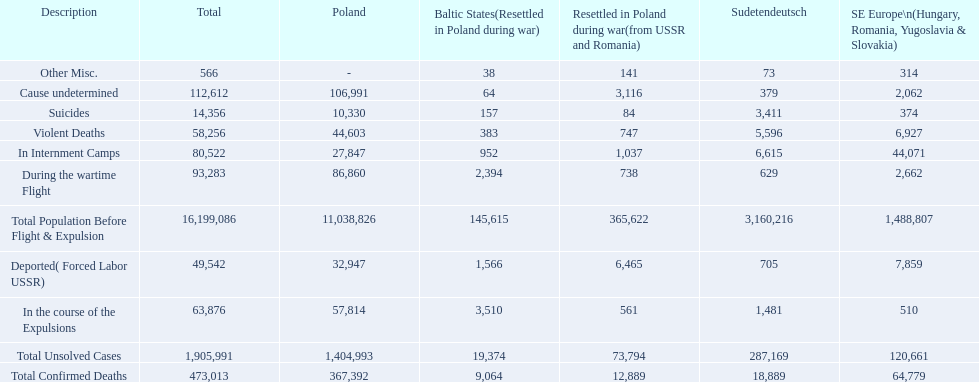How many total confirmed deaths were there in the baltic states? 9,064. How many deaths had an undetermined cause? 64. How many deaths in that region were miscellaneous? 38. Were there more deaths from an undetermined cause or that were listed as miscellaneous? Cause undetermined. 